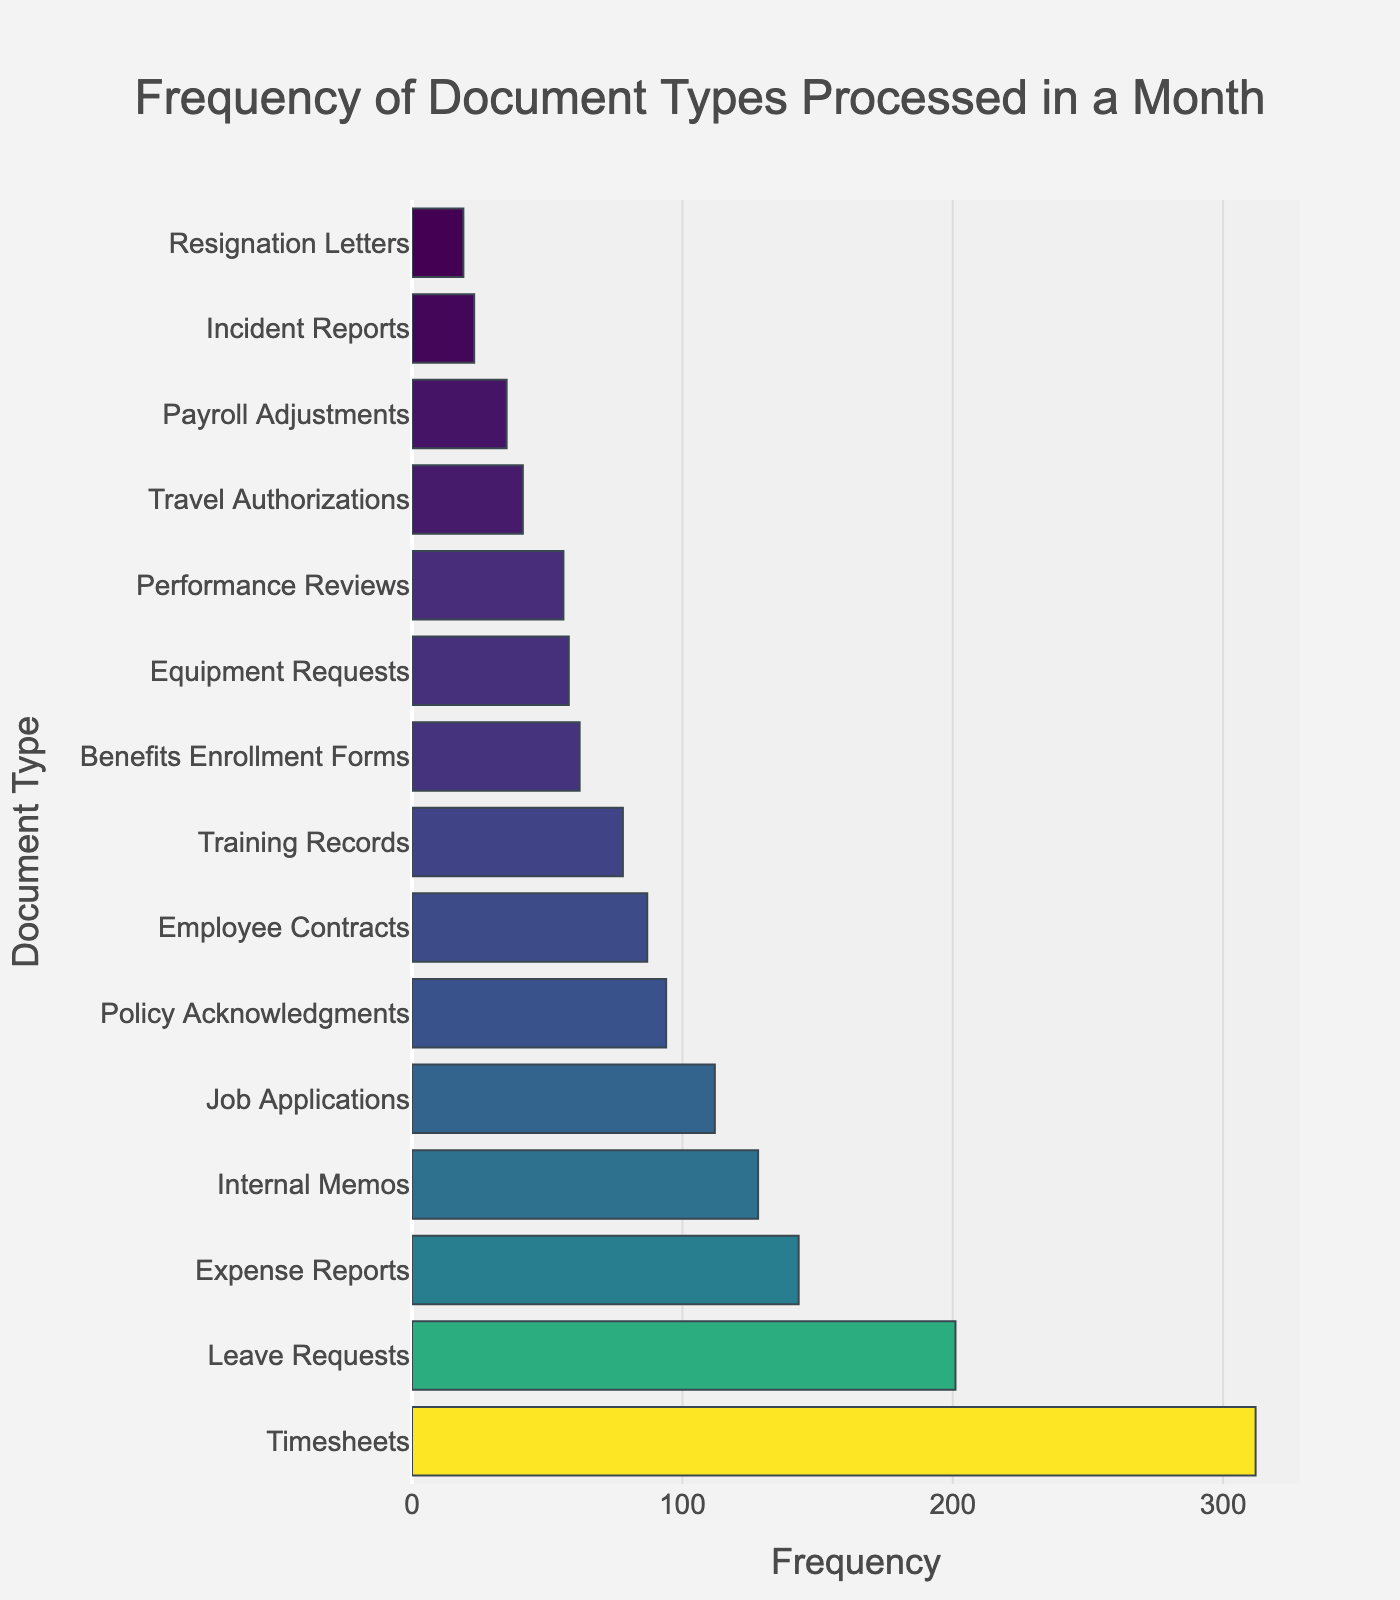Which document type has the highest frequency? The highest bar represents Timesheets with a frequency of 312.
Answer: Timesheets Which document type has the second-highest frequency? The second-highest bar represents Leave Requests with a frequency of 201.
Answer: Leave Requests What is the total frequency of Employee Contracts, Performance Reviews, and Equipment Requests combined? The frequencies are 87 (Employee Contracts), 56 (Performance Reviews), and 58 (Equipment Requests). Summing them gives 87 + 56 + 58 = 201.
Answer: 201 How many more Leave Requests are there compared to Expense Reports? Leave Requests have a frequency of 201, and Expense Reports have 143. The difference is 201 - 143 = 58.
Answer: 58 Which document has nearly half the frequency of Timesheets? Timesheets have a frequency of 312. Looking for half of 312 which is approximately 156, we see that Internal Memos with a frequency of 128 is close to this.
Answer: Internal Memos What is the combined frequency of the three least frequent document types? The frequencies for the three least frequent are Resignation Letters (19), Incident Reports (23), and Payroll Adjustments (35). The total is 19 + 23 + 35 = 77.
Answer: 77 How much greater is the frequency of the most frequent document type compared to the least frequent one? The most frequent is Timesheets (312), and the least frequent is Resignation Letters (19). The difference is 312 - 19 = 293.
Answer: 293 Which document type comes third in terms of frequency? The third highest frequency is for Expense Reports with a frequency of 143.
Answer: Expense Reports Which document types have frequencies greater than 100 but less than 200? The frequencies between 100 and 200 are Job Applications (112) and Internal Memos (128).
Answer: Job Applications and Internal Memos What is the average frequency of the given document types? To find the average, sum all frequencies and divide by the number of document types. Total frequency = 87 + 143 + 201 + 56 + 112 + 312 + 78 + 62 + 23 + 41 + 35 + 58 + 94 + 19 + 128 = 1449. There are 15 document types, so the average is 1449 / 15 = 96.6.
Answer: 96.6 